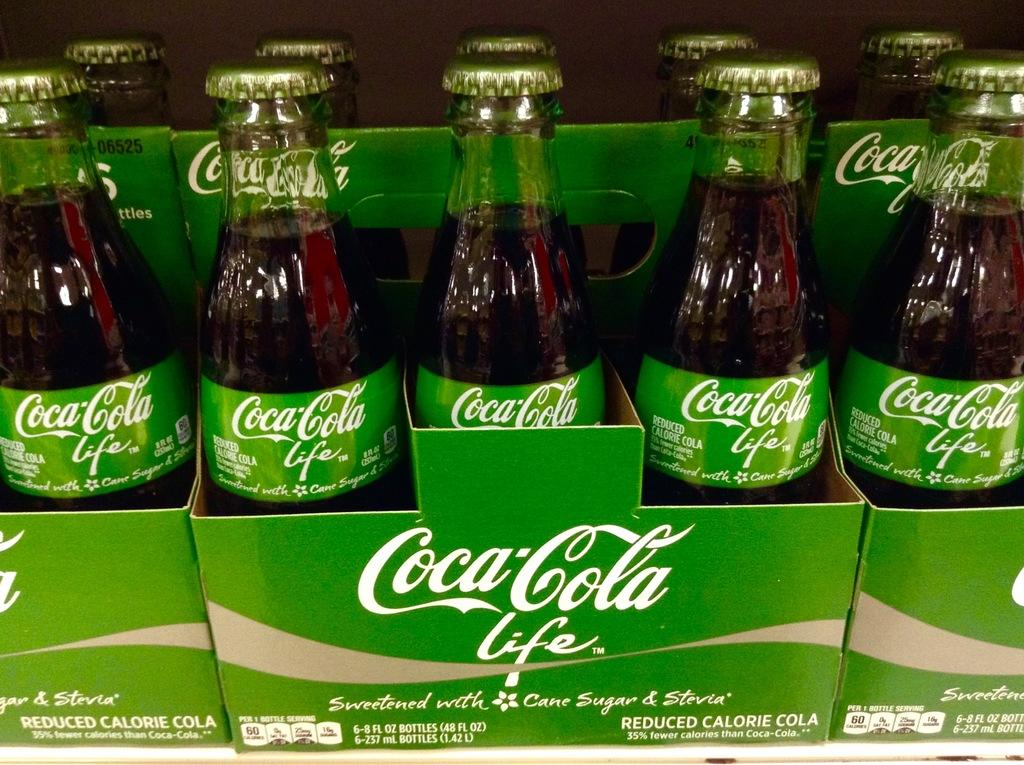<image>
Write a terse but informative summary of the picture. soe green six packs of Coca Cola Life reduced calorie soda 